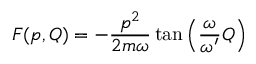<formula> <loc_0><loc_0><loc_500><loc_500>F ( p , Q ) = - \frac { p ^ { 2 } } { 2 m \omega } \tan \left ( \frac { \omega } { \omega ^ { \prime } } Q \right )</formula> 